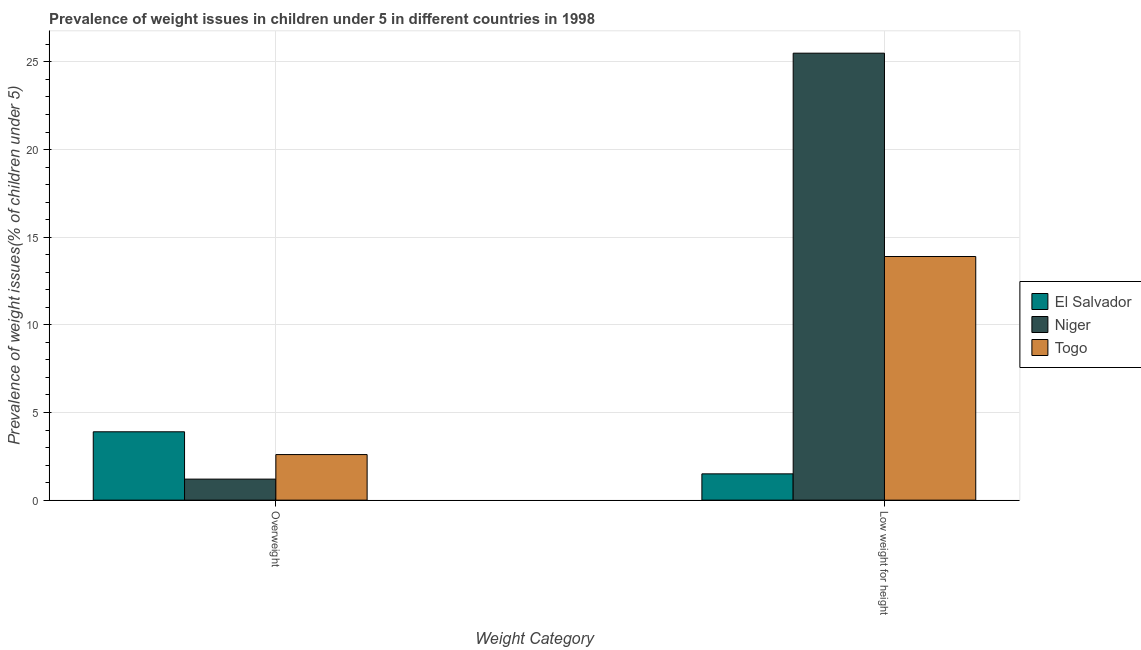How many groups of bars are there?
Your answer should be compact. 2. Are the number of bars per tick equal to the number of legend labels?
Offer a very short reply. Yes. How many bars are there on the 1st tick from the left?
Make the answer very short. 3. What is the label of the 1st group of bars from the left?
Offer a terse response. Overweight. What is the percentage of underweight children in Togo?
Your response must be concise. 13.9. Across all countries, what is the maximum percentage of overweight children?
Your answer should be compact. 3.9. Across all countries, what is the minimum percentage of underweight children?
Ensure brevity in your answer.  1.5. In which country was the percentage of underweight children maximum?
Your response must be concise. Niger. In which country was the percentage of overweight children minimum?
Your answer should be compact. Niger. What is the total percentage of underweight children in the graph?
Your answer should be compact. 40.9. What is the difference between the percentage of overweight children in Togo and that in Niger?
Provide a succinct answer. 1.4. What is the difference between the percentage of overweight children in Niger and the percentage of underweight children in El Salvador?
Keep it short and to the point. -0.3. What is the average percentage of underweight children per country?
Your answer should be very brief. 13.63. What is the difference between the percentage of underweight children and percentage of overweight children in Niger?
Offer a very short reply. 24.3. In how many countries, is the percentage of overweight children greater than 22 %?
Ensure brevity in your answer.  0. What is the ratio of the percentage of overweight children in Togo to that in Niger?
Your answer should be very brief. 2.17. What does the 1st bar from the left in Low weight for height represents?
Keep it short and to the point. El Salvador. What does the 3rd bar from the right in Low weight for height represents?
Provide a short and direct response. El Salvador. Are all the bars in the graph horizontal?
Your answer should be very brief. No. Does the graph contain any zero values?
Give a very brief answer. No. Does the graph contain grids?
Your answer should be compact. Yes. Where does the legend appear in the graph?
Offer a terse response. Center right. How are the legend labels stacked?
Give a very brief answer. Vertical. What is the title of the graph?
Your response must be concise. Prevalence of weight issues in children under 5 in different countries in 1998. What is the label or title of the X-axis?
Provide a short and direct response. Weight Category. What is the label or title of the Y-axis?
Offer a terse response. Prevalence of weight issues(% of children under 5). What is the Prevalence of weight issues(% of children under 5) of El Salvador in Overweight?
Offer a terse response. 3.9. What is the Prevalence of weight issues(% of children under 5) of Niger in Overweight?
Your answer should be compact. 1.2. What is the Prevalence of weight issues(% of children under 5) in Togo in Overweight?
Your answer should be compact. 2.6. What is the Prevalence of weight issues(% of children under 5) in Togo in Low weight for height?
Offer a very short reply. 13.9. Across all Weight Category, what is the maximum Prevalence of weight issues(% of children under 5) of El Salvador?
Keep it short and to the point. 3.9. Across all Weight Category, what is the maximum Prevalence of weight issues(% of children under 5) in Niger?
Make the answer very short. 25.5. Across all Weight Category, what is the maximum Prevalence of weight issues(% of children under 5) in Togo?
Keep it short and to the point. 13.9. Across all Weight Category, what is the minimum Prevalence of weight issues(% of children under 5) in El Salvador?
Ensure brevity in your answer.  1.5. Across all Weight Category, what is the minimum Prevalence of weight issues(% of children under 5) in Niger?
Make the answer very short. 1.2. Across all Weight Category, what is the minimum Prevalence of weight issues(% of children under 5) in Togo?
Provide a succinct answer. 2.6. What is the total Prevalence of weight issues(% of children under 5) in Niger in the graph?
Your response must be concise. 26.7. What is the difference between the Prevalence of weight issues(% of children under 5) in El Salvador in Overweight and that in Low weight for height?
Provide a succinct answer. 2.4. What is the difference between the Prevalence of weight issues(% of children under 5) of Niger in Overweight and that in Low weight for height?
Your response must be concise. -24.3. What is the difference between the Prevalence of weight issues(% of children under 5) in El Salvador in Overweight and the Prevalence of weight issues(% of children under 5) in Niger in Low weight for height?
Make the answer very short. -21.6. What is the average Prevalence of weight issues(% of children under 5) of Niger per Weight Category?
Your answer should be compact. 13.35. What is the average Prevalence of weight issues(% of children under 5) in Togo per Weight Category?
Your answer should be very brief. 8.25. What is the difference between the Prevalence of weight issues(% of children under 5) in El Salvador and Prevalence of weight issues(% of children under 5) in Niger in Overweight?
Provide a short and direct response. 2.7. What is the difference between the Prevalence of weight issues(% of children under 5) in Niger and Prevalence of weight issues(% of children under 5) in Togo in Overweight?
Keep it short and to the point. -1.4. What is the difference between the Prevalence of weight issues(% of children under 5) of El Salvador and Prevalence of weight issues(% of children under 5) of Niger in Low weight for height?
Your response must be concise. -24. What is the difference between the Prevalence of weight issues(% of children under 5) in El Salvador and Prevalence of weight issues(% of children under 5) in Togo in Low weight for height?
Your response must be concise. -12.4. What is the difference between the Prevalence of weight issues(% of children under 5) in Niger and Prevalence of weight issues(% of children under 5) in Togo in Low weight for height?
Ensure brevity in your answer.  11.6. What is the ratio of the Prevalence of weight issues(% of children under 5) of Niger in Overweight to that in Low weight for height?
Offer a terse response. 0.05. What is the ratio of the Prevalence of weight issues(% of children under 5) in Togo in Overweight to that in Low weight for height?
Offer a very short reply. 0.19. What is the difference between the highest and the second highest Prevalence of weight issues(% of children under 5) of Niger?
Keep it short and to the point. 24.3. What is the difference between the highest and the lowest Prevalence of weight issues(% of children under 5) of Niger?
Give a very brief answer. 24.3. 